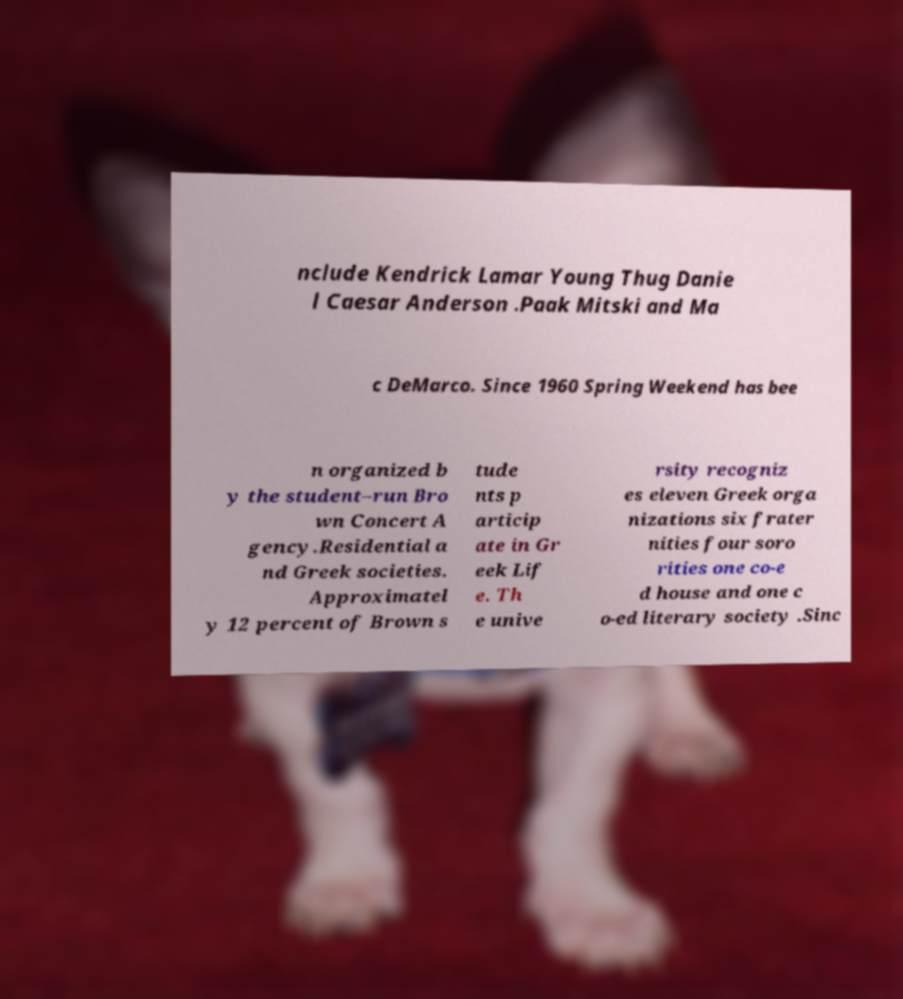For documentation purposes, I need the text within this image transcribed. Could you provide that? nclude Kendrick Lamar Young Thug Danie l Caesar Anderson .Paak Mitski and Ma c DeMarco. Since 1960 Spring Weekend has bee n organized b y the student–run Bro wn Concert A gency.Residential a nd Greek societies. Approximatel y 12 percent of Brown s tude nts p articip ate in Gr eek Lif e. Th e unive rsity recogniz es eleven Greek orga nizations six frater nities four soro rities one co-e d house and one c o-ed literary society .Sinc 